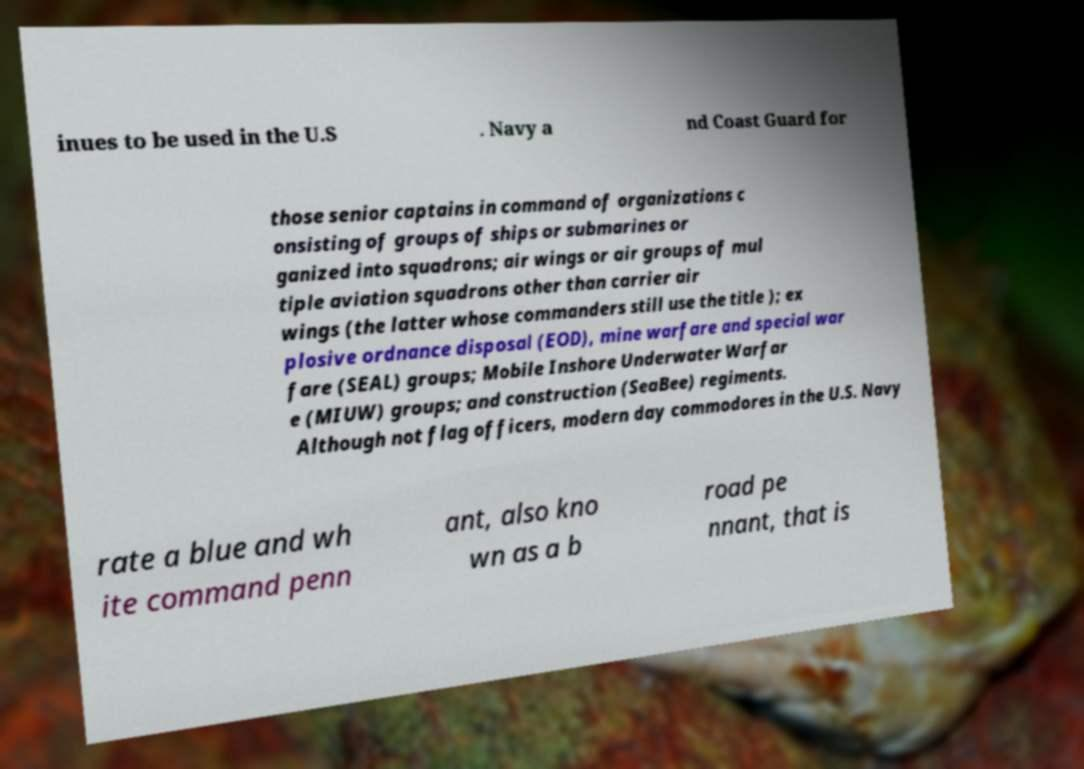For documentation purposes, I need the text within this image transcribed. Could you provide that? inues to be used in the U.S . Navy a nd Coast Guard for those senior captains in command of organizations c onsisting of groups of ships or submarines or ganized into squadrons; air wings or air groups of mul tiple aviation squadrons other than carrier air wings (the latter whose commanders still use the title ); ex plosive ordnance disposal (EOD), mine warfare and special war fare (SEAL) groups; Mobile Inshore Underwater Warfar e (MIUW) groups; and construction (SeaBee) regiments. Although not flag officers, modern day commodores in the U.S. Navy rate a blue and wh ite command penn ant, also kno wn as a b road pe nnant, that is 